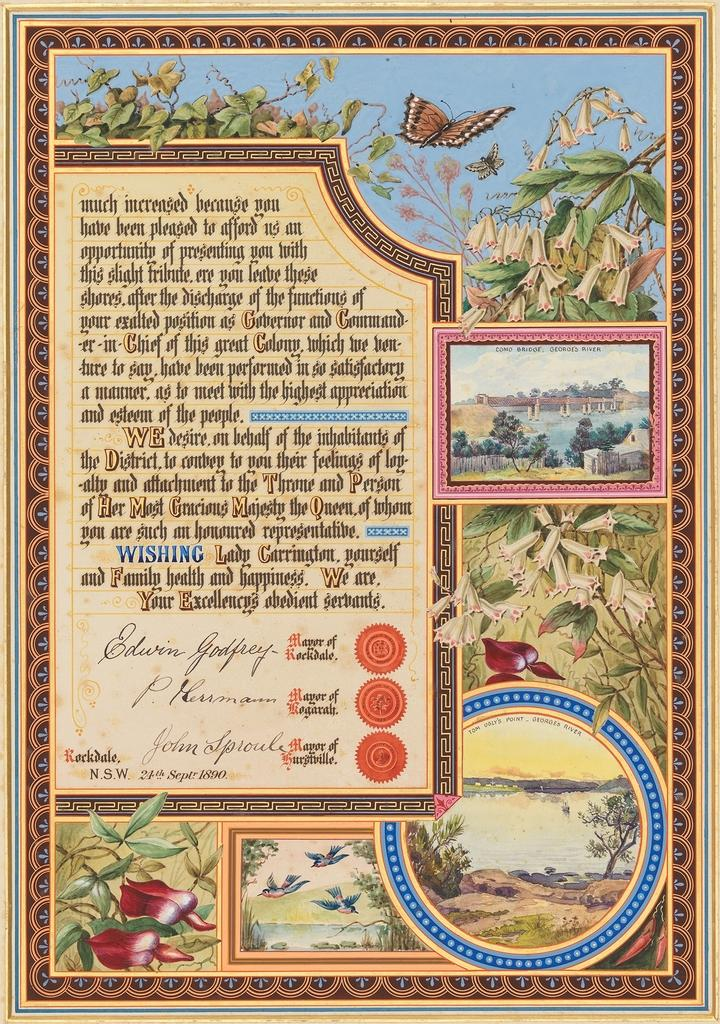<image>
Describe the image concisely. Poster with butterflies and plants in the background with a blue word that says "WISHING". 